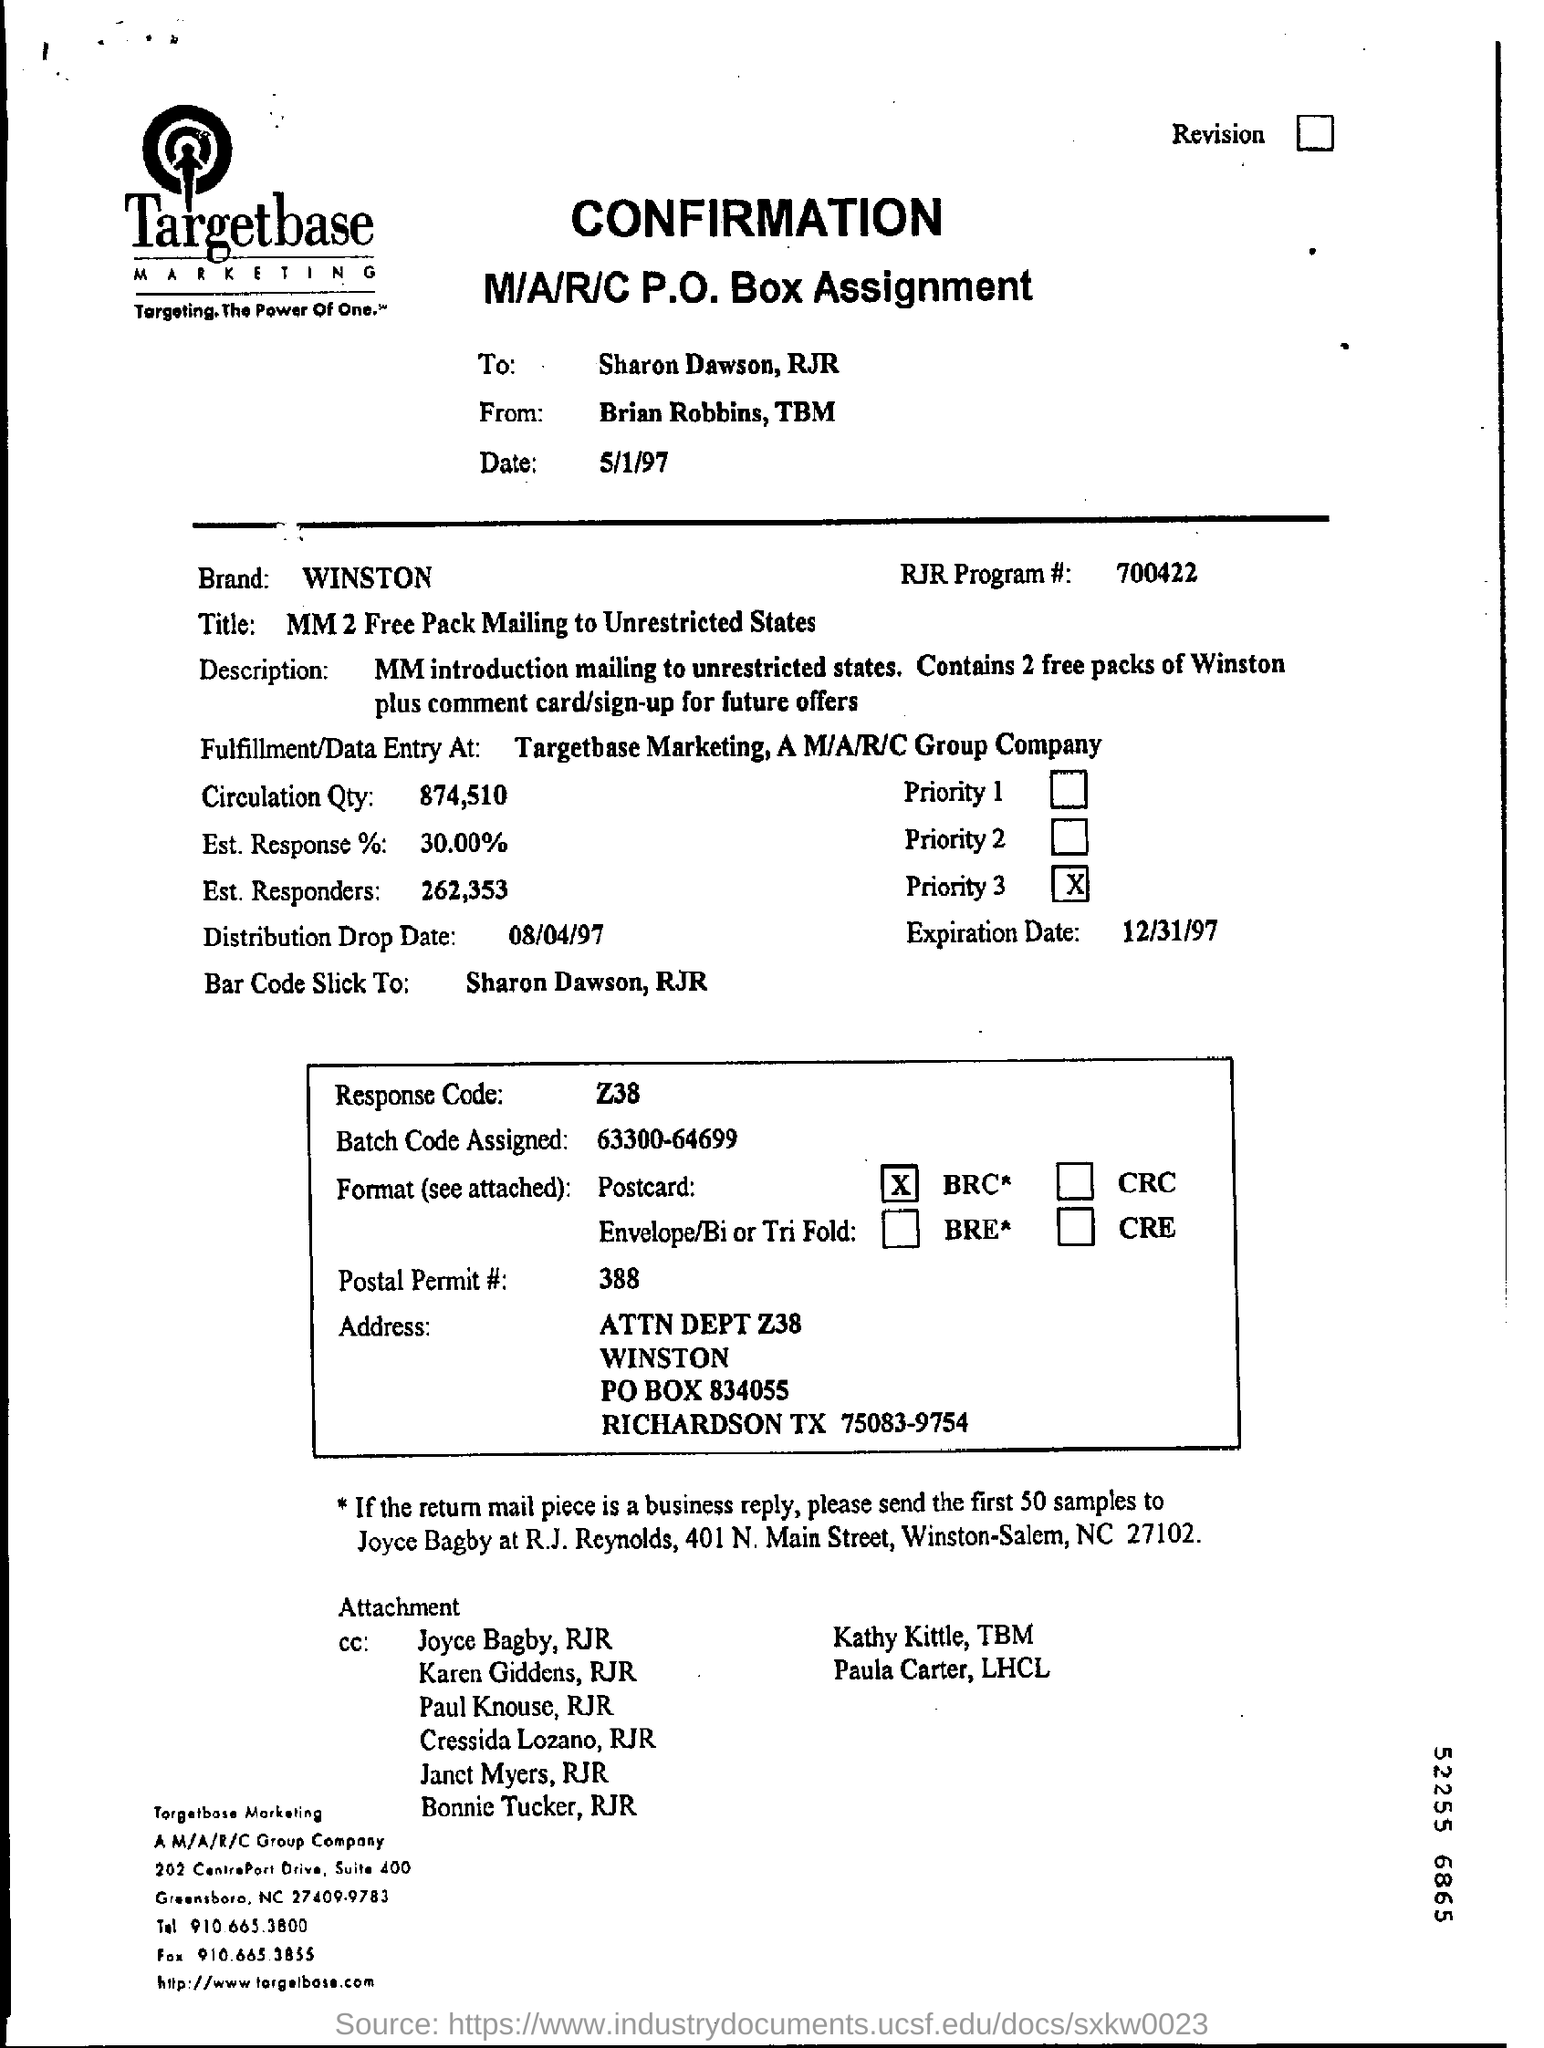Indicate a few pertinent items in this graphic. Mention the expiration date, which is December 31, 1997. The RJR program number is 700422. It is necessary to send 50 samples to Joyce Bagby. The brand name is WINSTON. The AM/A/R/C Group Company is located in North Carolina. 